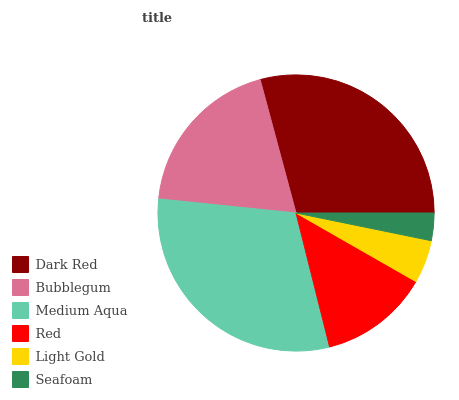Is Seafoam the minimum?
Answer yes or no. Yes. Is Medium Aqua the maximum?
Answer yes or no. Yes. Is Bubblegum the minimum?
Answer yes or no. No. Is Bubblegum the maximum?
Answer yes or no. No. Is Dark Red greater than Bubblegum?
Answer yes or no. Yes. Is Bubblegum less than Dark Red?
Answer yes or no. Yes. Is Bubblegum greater than Dark Red?
Answer yes or no. No. Is Dark Red less than Bubblegum?
Answer yes or no. No. Is Bubblegum the high median?
Answer yes or no. Yes. Is Red the low median?
Answer yes or no. Yes. Is Seafoam the high median?
Answer yes or no. No. Is Medium Aqua the low median?
Answer yes or no. No. 